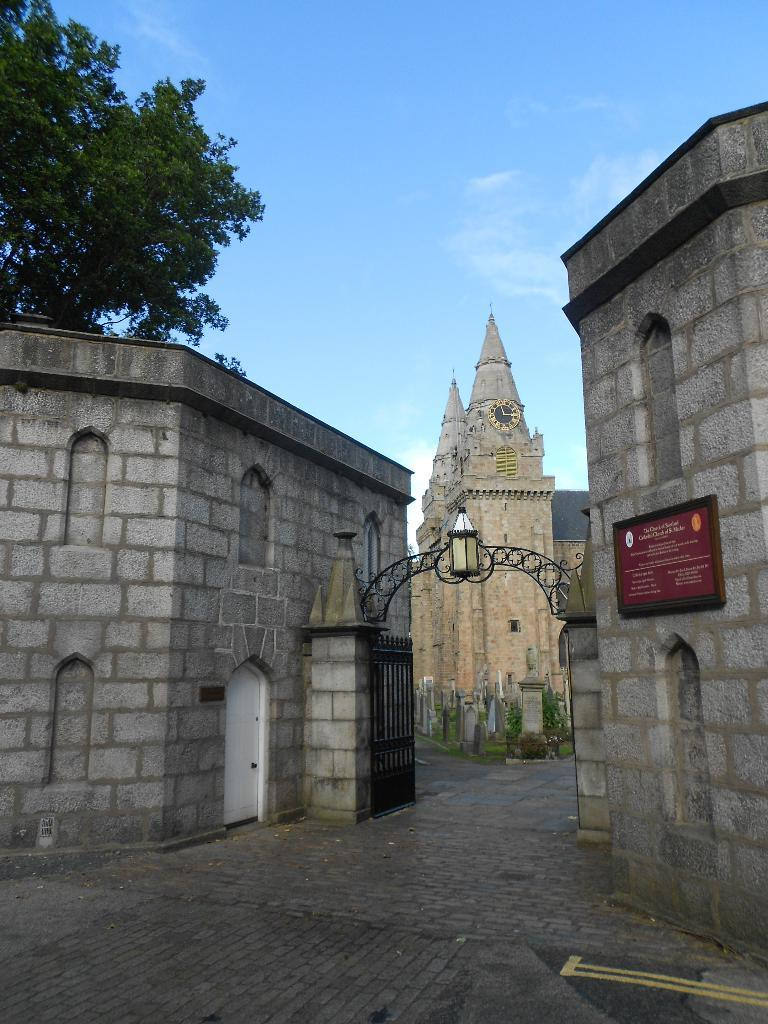What is the main structure visible in the image? There is a gate in the image. What is the color of the door near the gate? There is a white color door in the image. Can you describe the lighting in the image? There is a light on an object in the image. What is attached to the wall in the image? There is a board attached to a wall in the image. What can be seen in the background of the image? There is a clock tower, a building, a tree, and the sky visible in the background of the image. What type of disease is affecting the tree in the image? There is no indication of any disease affecting the tree in the image; it appears to be a healthy tree. 